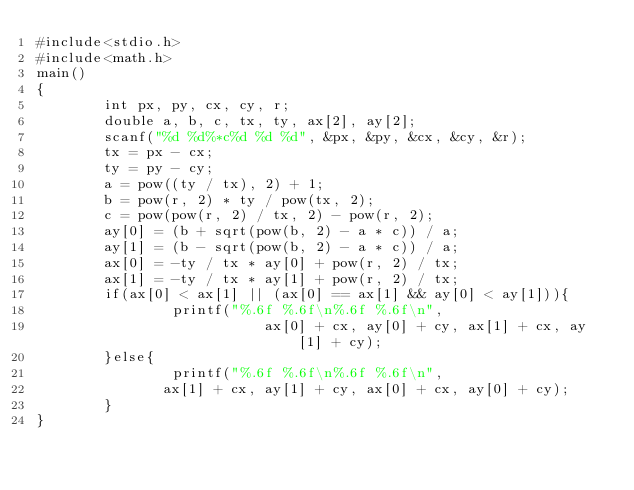<code> <loc_0><loc_0><loc_500><loc_500><_C_>#include<stdio.h>
#include<math.h>
main()
{
        int px, py, cx, cy, r;
        double a, b, c, tx, ty, ax[2], ay[2];
        scanf("%d %d%*c%d %d %d", &px, &py, &cx, &cy, &r);
        tx = px - cx;
        ty = py - cy;
        a = pow((ty / tx), 2) + 1;
        b = pow(r, 2) * ty / pow(tx, 2);
        c = pow(pow(r, 2) / tx, 2) - pow(r, 2);
        ay[0] = (b + sqrt(pow(b, 2) - a * c)) / a;
        ay[1] = (b - sqrt(pow(b, 2) - a * c)) / a;
        ax[0] = -ty / tx * ay[0] + pow(r, 2) / tx;
        ax[1] = -ty / tx * ay[1] + pow(r, 2) / tx;
        if(ax[0] < ax[1] || (ax[0] == ax[1] && ay[0] < ay[1])){
                printf("%.6f %.6f\n%.6f %.6f\n",
                           ax[0] + cx, ay[0] + cy, ax[1] + cx, ay[1] + cy);
        }else{
                printf("%.6f %.6f\n%.6f %.6f\n",
               ax[1] + cx, ay[1] + cy, ax[0] + cx, ay[0] + cy);
        }
}</code> 